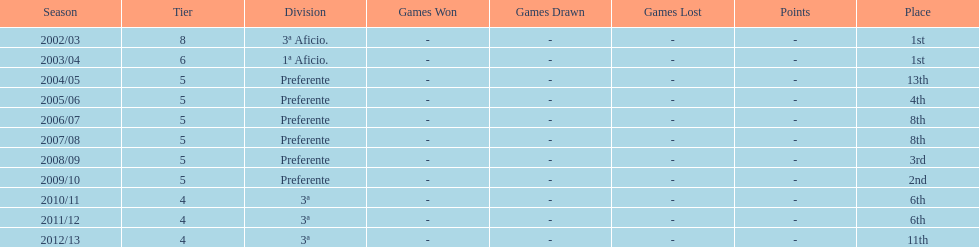How long has internacional de madrid cf been playing in the 3ª division? 3. 